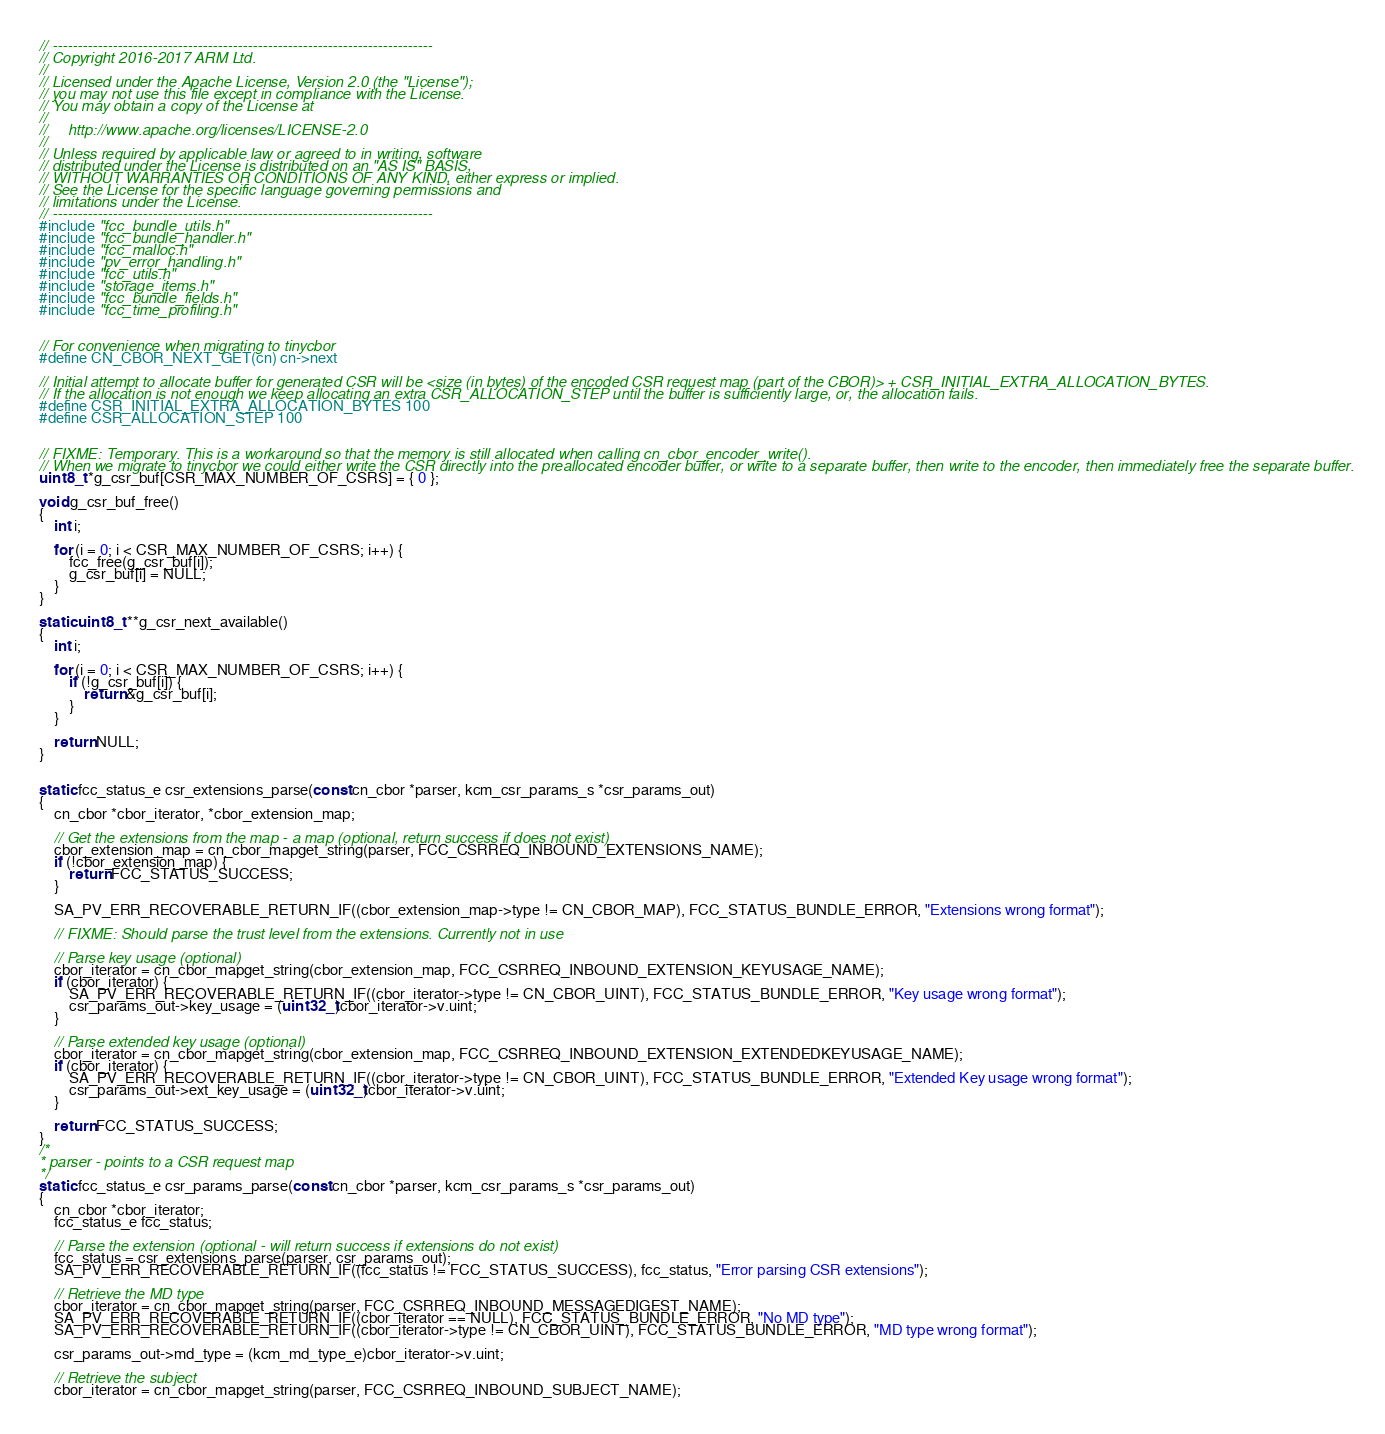Convert code to text. <code><loc_0><loc_0><loc_500><loc_500><_C_>// ----------------------------------------------------------------------------
// Copyright 2016-2017 ARM Ltd.
//  
// Licensed under the Apache License, Version 2.0 (the "License");
// you may not use this file except in compliance with the License.
// You may obtain a copy of the License at
//  
//     http://www.apache.org/licenses/LICENSE-2.0
//  
// Unless required by applicable law or agreed to in writing, software
// distributed under the License is distributed on an "AS IS" BASIS,
// WITHOUT WARRANTIES OR CONDITIONS OF ANY KIND, either express or implied.
// See the License for the specific language governing permissions and
// limitations under the License.
// ----------------------------------------------------------------------------
#include "fcc_bundle_utils.h"
#include "fcc_bundle_handler.h"
#include "fcc_malloc.h"
#include "pv_error_handling.h"
#include "fcc_utils.h"
#include "storage_items.h"
#include "fcc_bundle_fields.h"
#include "fcc_time_profiling.h"


// For convenience when migrating to tinycbor
#define CN_CBOR_NEXT_GET(cn) cn->next 

// Initial attempt to allocate buffer for generated CSR will be <size (in bytes) of the encoded CSR request map (part of the CBOR)> + CSR_INITIAL_EXTRA_ALLOCATION_BYTES.
// If the allocation is not enough we keep allocating an extra CSR_ALLOCATION_STEP until the buffer is sufficiently large, or, the allocation fails.
#define CSR_INITIAL_EXTRA_ALLOCATION_BYTES 100
#define CSR_ALLOCATION_STEP 100


// FIXME: Temporary. This is a workaround so that the memory is still allocated when calling cn_cbor_encoder_write().
// When we migrate to tinycbor we could either write the CSR directly into the preallocated encoder buffer, or write to a separate buffer, then write to the encoder, then immediately free the separate buffer.
uint8_t *g_csr_buf[CSR_MAX_NUMBER_OF_CSRS] = { 0 };

void g_csr_buf_free()
{
    int i;

    for (i = 0; i < CSR_MAX_NUMBER_OF_CSRS; i++) {
        fcc_free(g_csr_buf[i]);
        g_csr_buf[i] = NULL;
    }
}

static uint8_t **g_csr_next_available()
{
    int i;

    for (i = 0; i < CSR_MAX_NUMBER_OF_CSRS; i++) {
        if (!g_csr_buf[i]) {
            return &g_csr_buf[i];
        }
    }

    return NULL;
}


static fcc_status_e csr_extensions_parse(const cn_cbor *parser, kcm_csr_params_s *csr_params_out)
{
    cn_cbor *cbor_iterator, *cbor_extension_map;

    // Get the extensions from the map - a map (optional, return success if does not exist)
    cbor_extension_map = cn_cbor_mapget_string(parser, FCC_CSRREQ_INBOUND_EXTENSIONS_NAME);
    if (!cbor_extension_map) {
        return FCC_STATUS_SUCCESS;
    }

    SA_PV_ERR_RECOVERABLE_RETURN_IF((cbor_extension_map->type != CN_CBOR_MAP), FCC_STATUS_BUNDLE_ERROR, "Extensions wrong format");

    // FIXME: Should parse the trust level from the extensions. Currently not in use

    // Parse key usage (optional)
    cbor_iterator = cn_cbor_mapget_string(cbor_extension_map, FCC_CSRREQ_INBOUND_EXTENSION_KEYUSAGE_NAME);
    if (cbor_iterator) {
        SA_PV_ERR_RECOVERABLE_RETURN_IF((cbor_iterator->type != CN_CBOR_UINT), FCC_STATUS_BUNDLE_ERROR, "Key usage wrong format");
        csr_params_out->key_usage = (uint32_t)cbor_iterator->v.uint;
    }

    // Parse extended key usage (optional)
    cbor_iterator = cn_cbor_mapget_string(cbor_extension_map, FCC_CSRREQ_INBOUND_EXTENSION_EXTENDEDKEYUSAGE_NAME);
    if (cbor_iterator) {
        SA_PV_ERR_RECOVERABLE_RETURN_IF((cbor_iterator->type != CN_CBOR_UINT), FCC_STATUS_BUNDLE_ERROR, "Extended Key usage wrong format");
        csr_params_out->ext_key_usage = (uint32_t)cbor_iterator->v.uint;
    }

    return FCC_STATUS_SUCCESS;
}
/*
* parser - points to a CSR request map
*/
static fcc_status_e csr_params_parse(const cn_cbor *parser, kcm_csr_params_s *csr_params_out)
{
    cn_cbor *cbor_iterator;
    fcc_status_e fcc_status;

    // Parse the extension (optional - will return success if extensions do not exist)
    fcc_status = csr_extensions_parse(parser, csr_params_out);
    SA_PV_ERR_RECOVERABLE_RETURN_IF((fcc_status != FCC_STATUS_SUCCESS), fcc_status, "Error parsing CSR extensions");

    // Retrieve the MD type
    cbor_iterator = cn_cbor_mapget_string(parser, FCC_CSRREQ_INBOUND_MESSAGEDIGEST_NAME);
    SA_PV_ERR_RECOVERABLE_RETURN_IF((cbor_iterator == NULL), FCC_STATUS_BUNDLE_ERROR, "No MD type");
    SA_PV_ERR_RECOVERABLE_RETURN_IF((cbor_iterator->type != CN_CBOR_UINT), FCC_STATUS_BUNDLE_ERROR, "MD type wrong format");

    csr_params_out->md_type = (kcm_md_type_e)cbor_iterator->v.uint;

    // Retrieve the subject
    cbor_iterator = cn_cbor_mapget_string(parser, FCC_CSRREQ_INBOUND_SUBJECT_NAME);</code> 